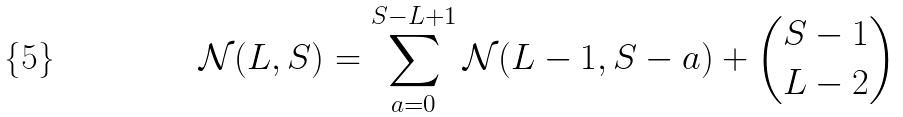<formula> <loc_0><loc_0><loc_500><loc_500>\mathcal { N } ( L , S ) = \sum _ { a = 0 } ^ { S - L + 1 } \mathcal { N } ( L - 1 , S - a ) + \binom { S - 1 } { L - 2 }</formula> 